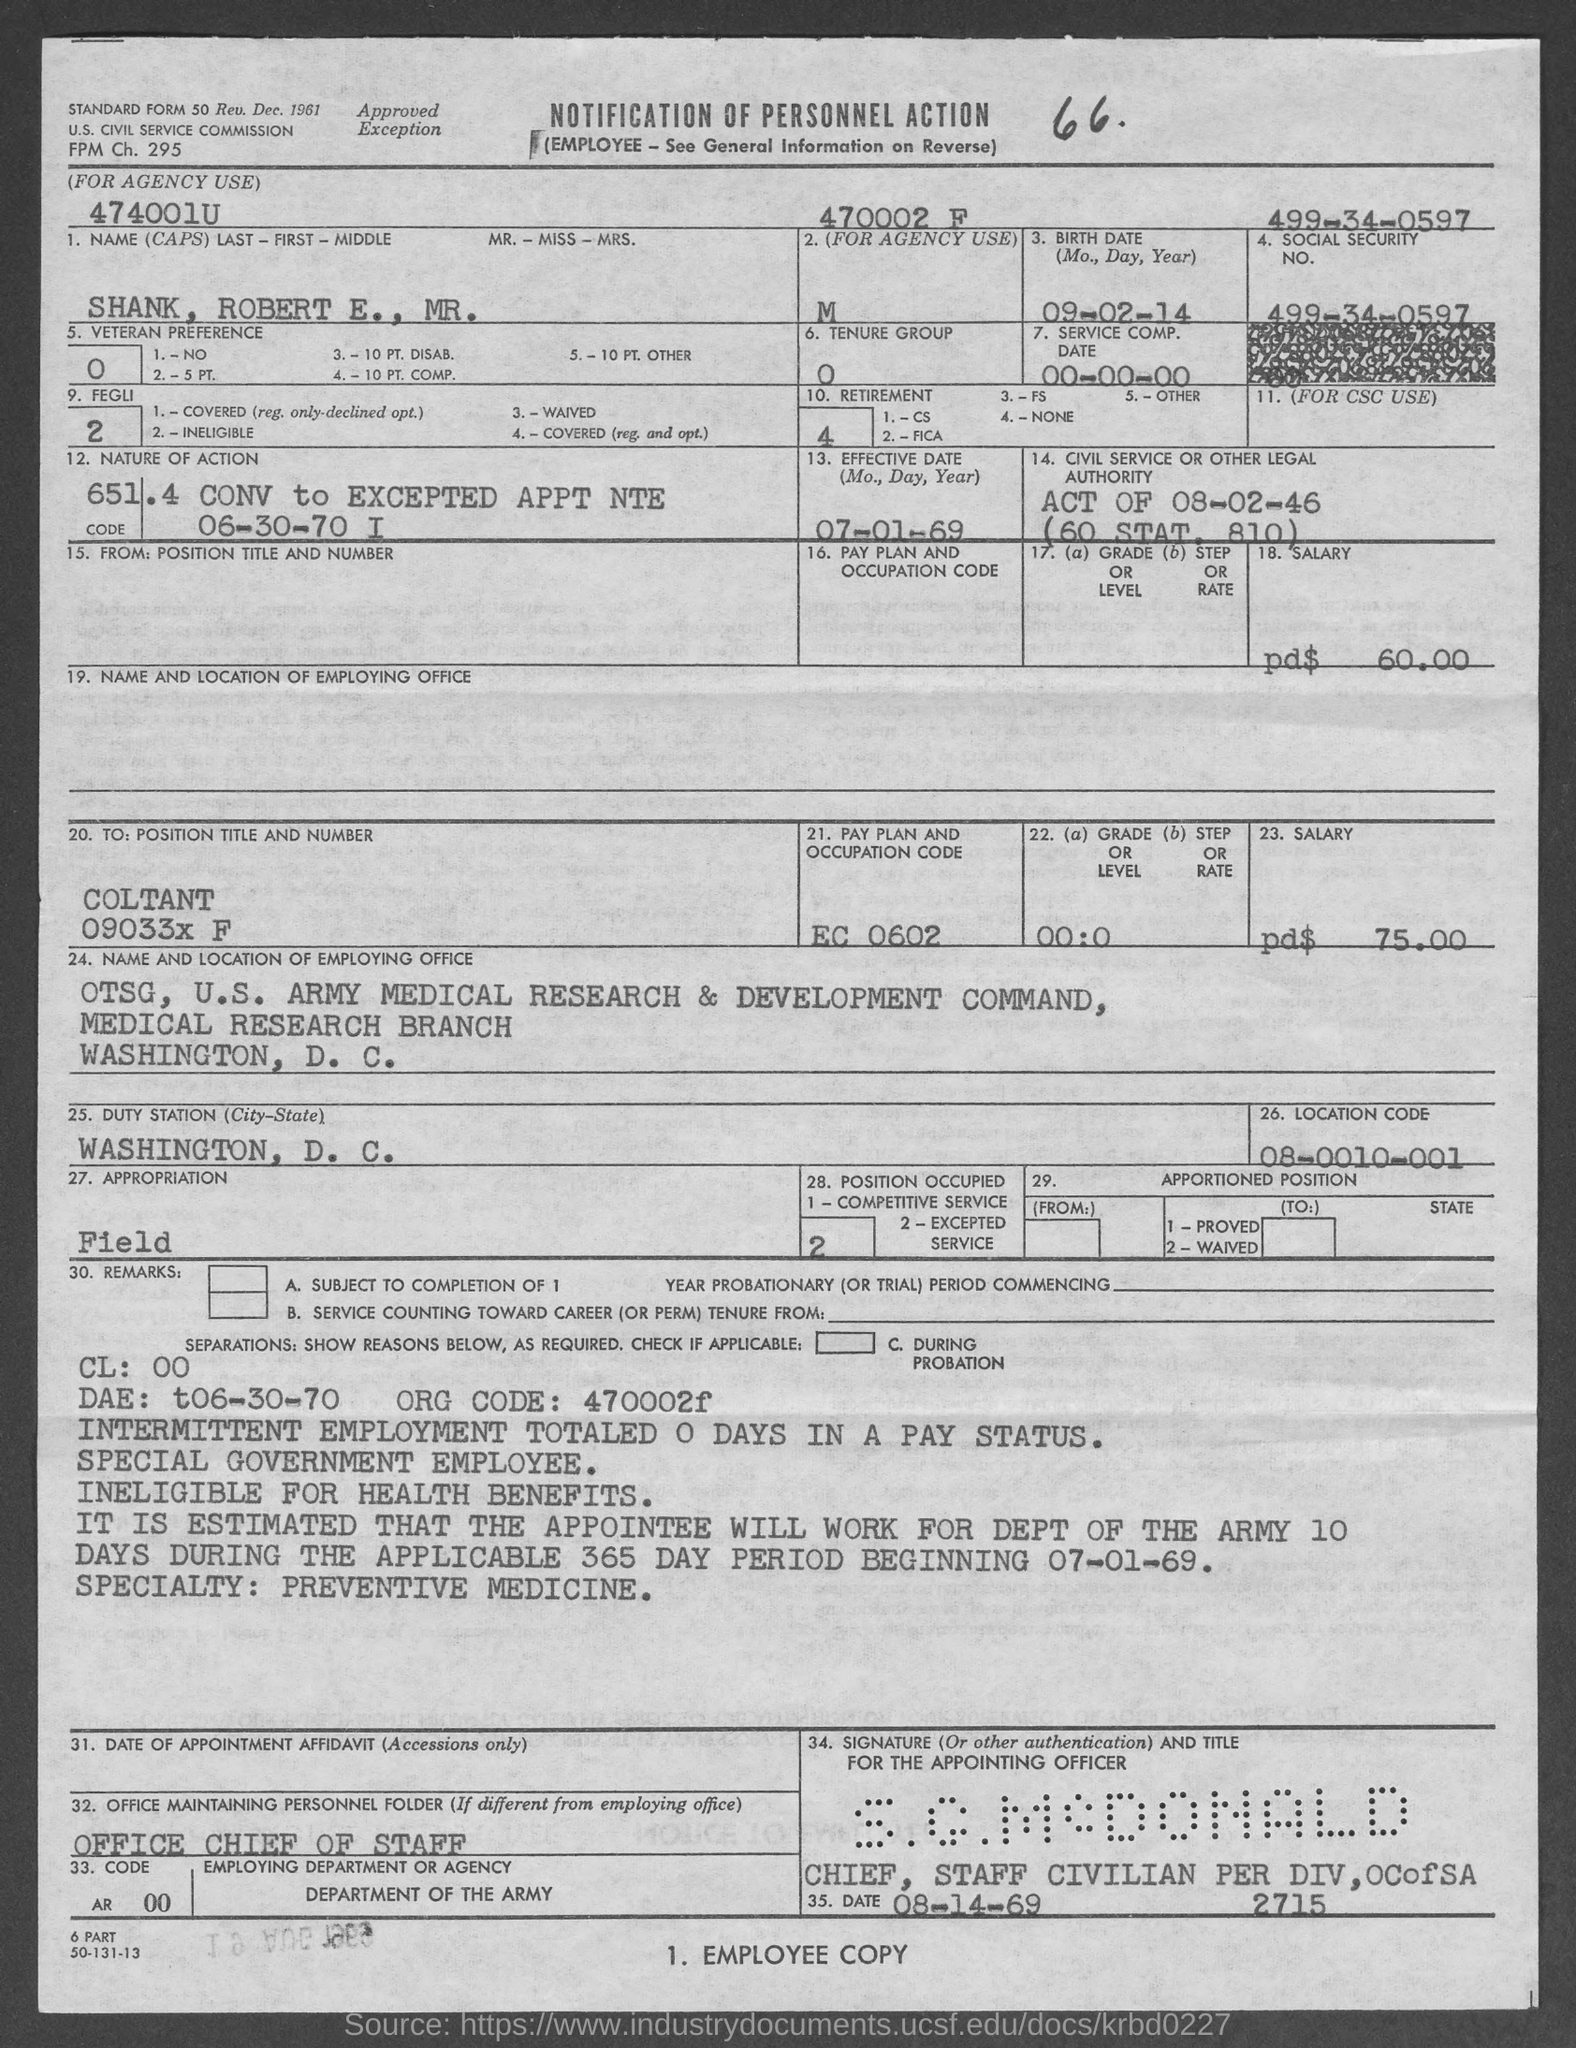Point out several critical features in this image. The location code is 08-0010-001. The name of the candidate is Shank, Robert E., Mr. I would like to know the pay plan and occupation code for EC 0602. The social security number 499-34-0597 belongs to... 